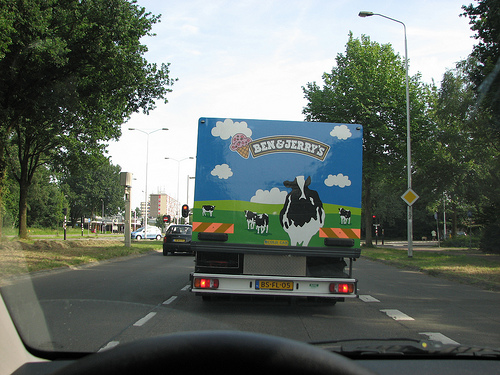<image>
Can you confirm if the truck is in front of the car? Yes. The truck is positioned in front of the car, appearing closer to the camera viewpoint. Where is the truck in relation to the car? Is it in front of the car? No. The truck is not in front of the car. The spatial positioning shows a different relationship between these objects. 